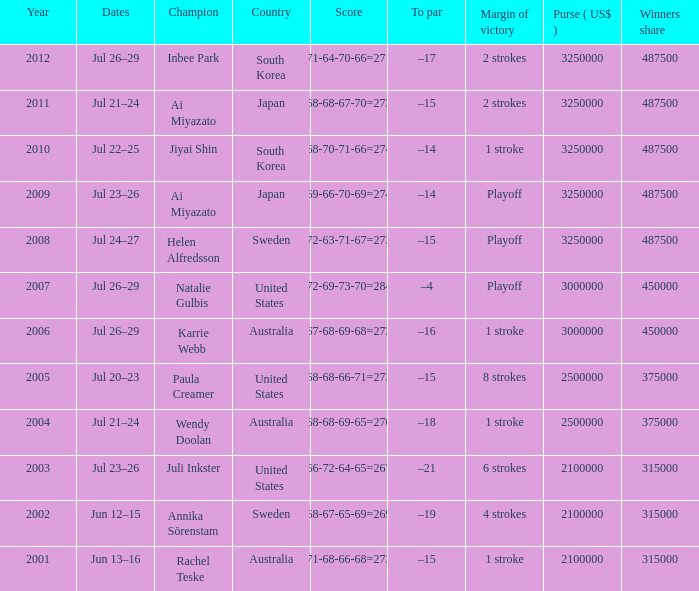What is the lowest year listed? 2001.0. 